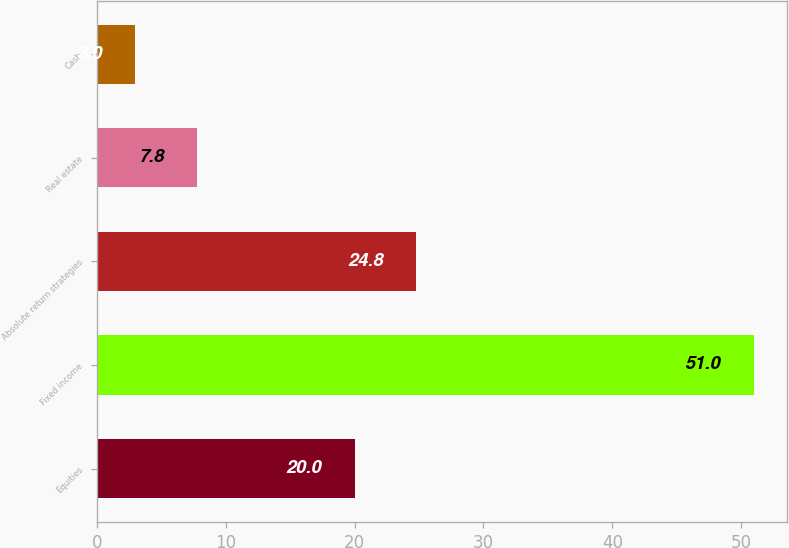<chart> <loc_0><loc_0><loc_500><loc_500><bar_chart><fcel>Equities<fcel>Fixed income<fcel>Absolute return strategies<fcel>Real estate<fcel>Cash<nl><fcel>20<fcel>51<fcel>24.8<fcel>7.8<fcel>3<nl></chart> 